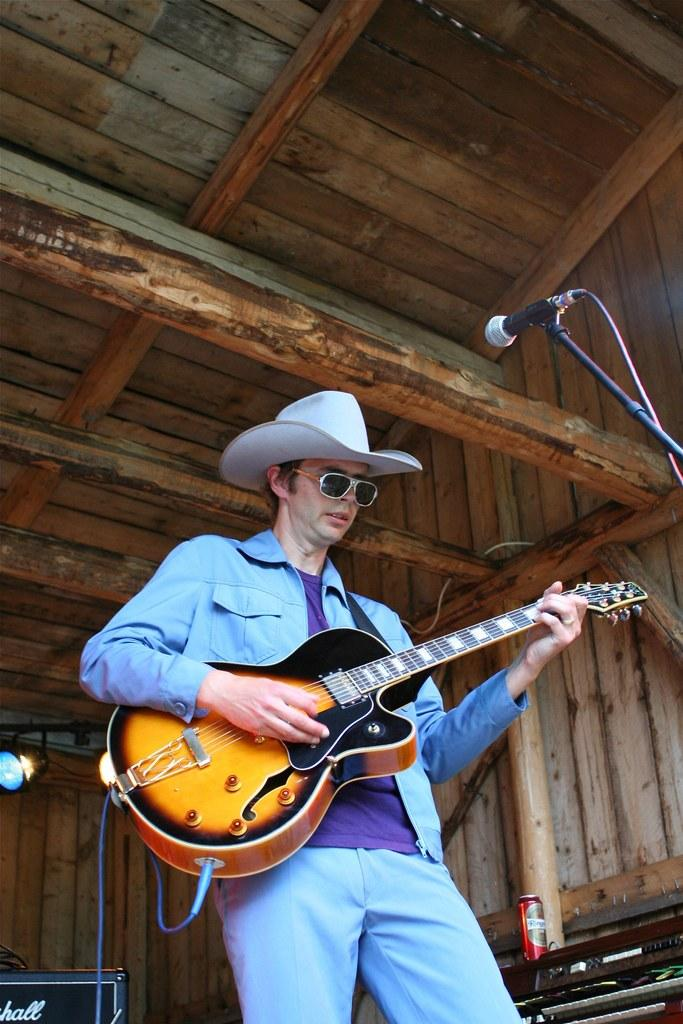Who is the main subject in the image? There is a man in the image. What is the man doing in the image? The man is standing and playing a guitar. What object is in front of the man? There is a microphone in front of the man. Where is the family located in the image? There is no family present in the image; it only features a man playing a guitar. What type of stove is visible in the image? There is no stove present in the image. 